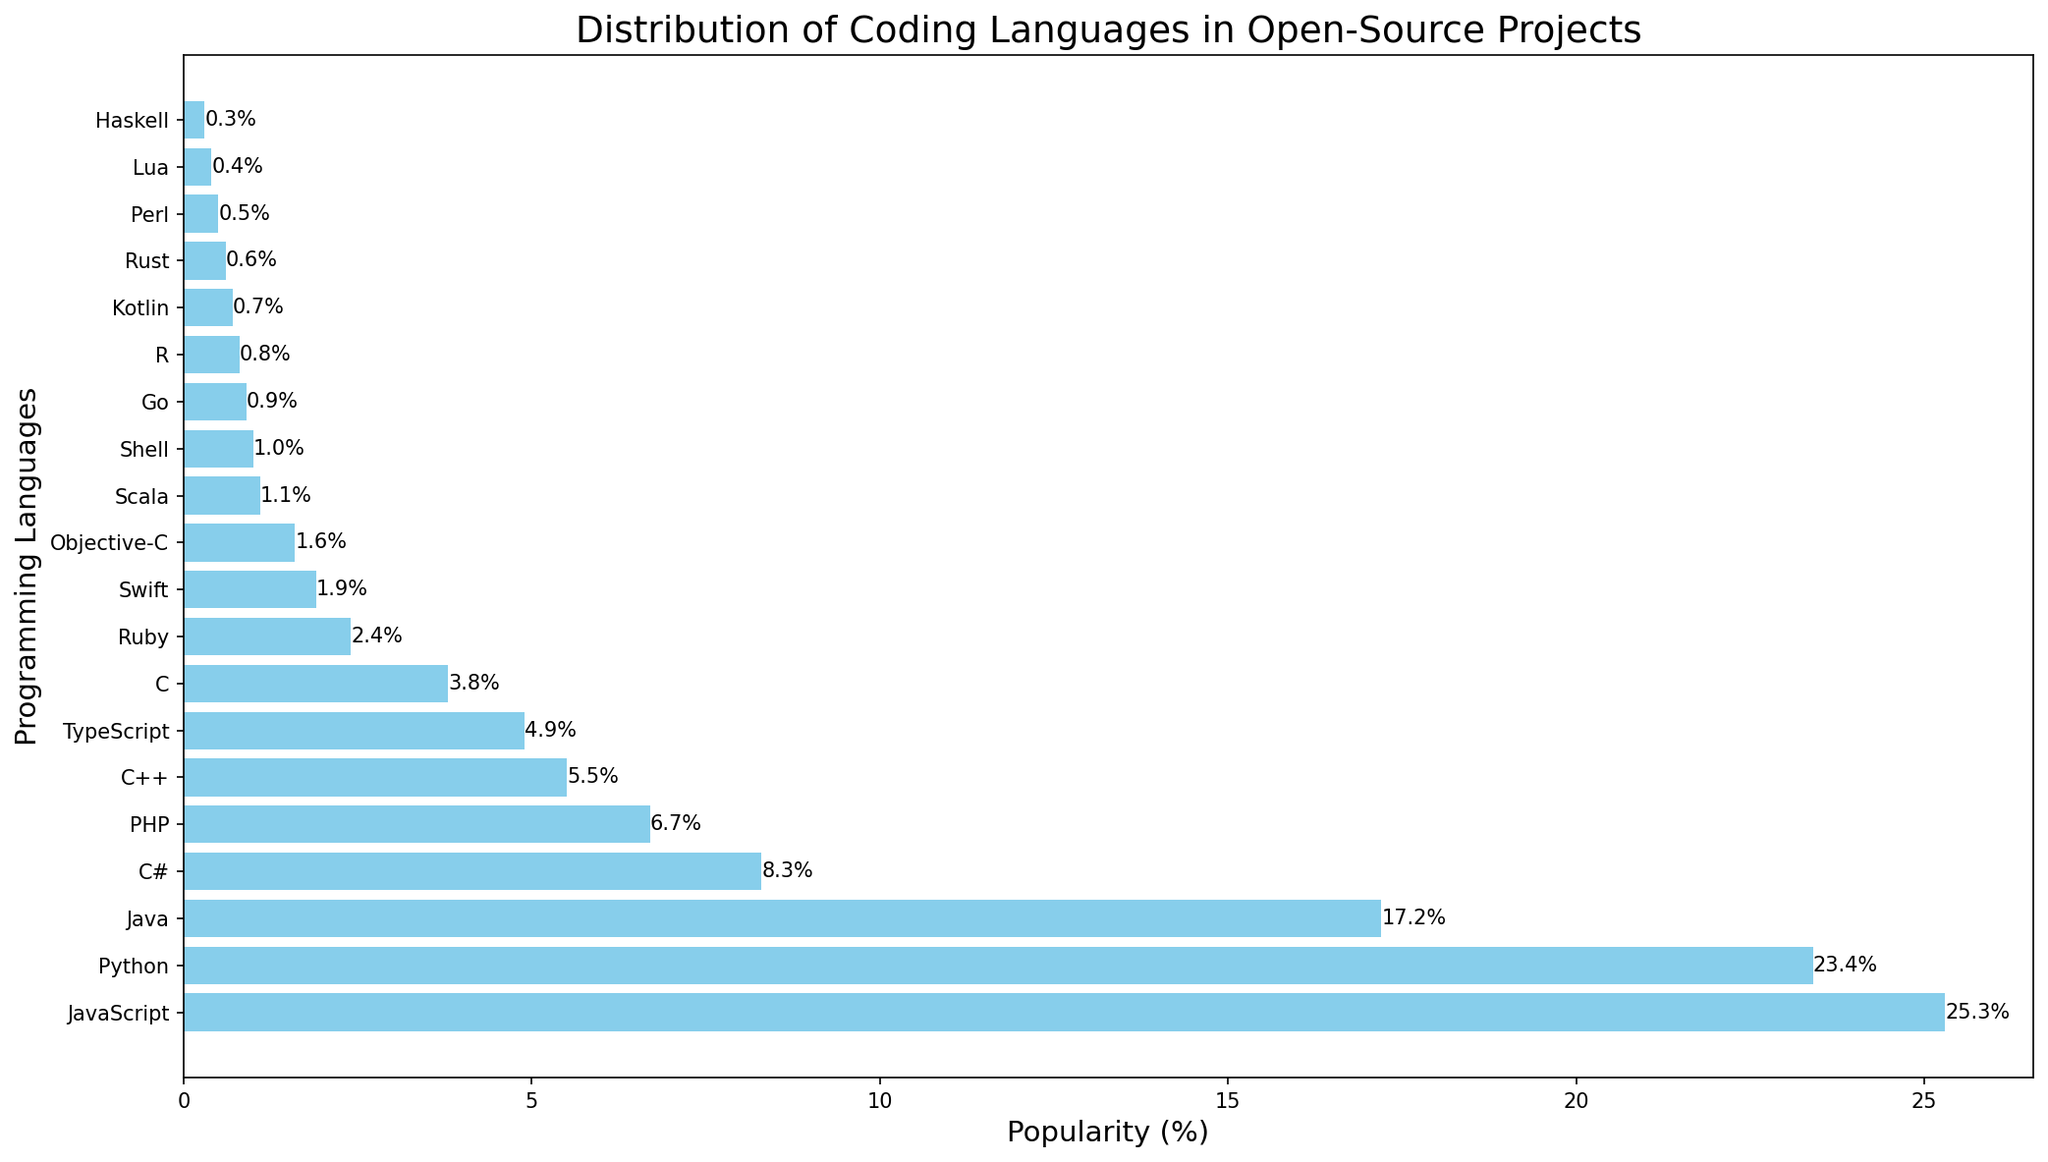What is the most popular programming language for open-source projects? The height of the bars represents the popularity of each programming language. The language with the highest bar is JavaScript.
Answer: JavaScript Which language is more popular, Python or Java? To answer this, compare the heights of the bars representing Python and Java. Python has a higher bar than Java, indicating it is more popular.
Answer: Python What is the combined popularity of the top three languages? The top three languages are JavaScript (25.3%), Python (23.4%), and Java (17.2%). Adding their popularity percentages gives 25.3 + 23.4 + 17.2 = 65.9%.
Answer: 65.9% Which language is least popular, and what is its popularity percentage? Look for the language with the shortest bar. It is Haskell with a popularity of 0.3%.
Answer: Haskell, 0.3% How much more popular is C# compared to Kotlin? C# has a popularity of 8.3%, and Kotlin has 0.7%. Subtracting these gives 8.3 - 0.7 = 7.6%.
Answer: 7.6% What is the average popularity of TypeScript, C, and Ruby? The popularity of TypeScript is 4.9%, C is 3.8%, and Ruby is 2.4%. Adding these and dividing by 3 gives (4.9 + 3.8 + 2.4) / 3 = 3.7%.
Answer: 3.7% Is Swift more popular than Scala? Compare the lengths of the bars for Swift and Scala. Swift (1.9%) is more popular than Scala (1.1%).
Answer: Yes By how much does the popularity of PHP exceed that of Go? PHP's popularity is 6.7%, and Go's is 0.9%. Subtracting gives 6.7 - 0.9 = 5.8%.
Answer: 5.8% Which languages have a popularity between 2% and 5%? The bars falling within this range are for Ruby (2.4%), Swift (1.9%, close), Objective-C (1.6%, close), and TypeScript (4.9%).
Answer: Ruby, TypeScript Calculate the percentage difference between JavaScript and Python. The popularity of JavaScript is 25.3%, and Python is 23.4%. The percentage difference is calculated as ((25.3 - 23.4) / 23.4) * 100 = 8.12%.
Answer: 8.12% 